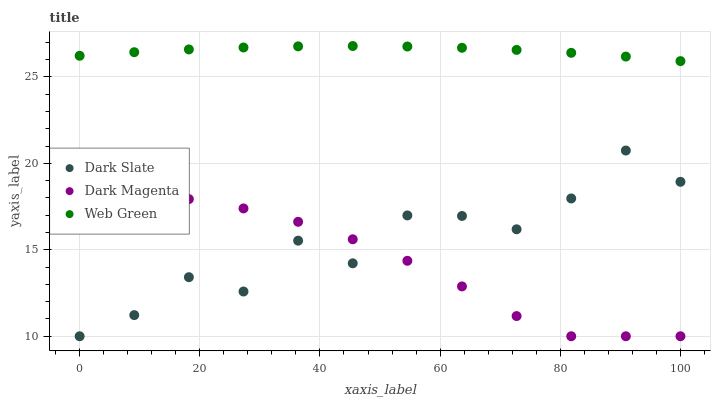Does Dark Magenta have the minimum area under the curve?
Answer yes or no. Yes. Does Web Green have the maximum area under the curve?
Answer yes or no. Yes. Does Web Green have the minimum area under the curve?
Answer yes or no. No. Does Dark Magenta have the maximum area under the curve?
Answer yes or no. No. Is Web Green the smoothest?
Answer yes or no. Yes. Is Dark Slate the roughest?
Answer yes or no. Yes. Is Dark Magenta the smoothest?
Answer yes or no. No. Is Dark Magenta the roughest?
Answer yes or no. No. Does Dark Slate have the lowest value?
Answer yes or no. Yes. Does Web Green have the lowest value?
Answer yes or no. No. Does Web Green have the highest value?
Answer yes or no. Yes. Does Dark Magenta have the highest value?
Answer yes or no. No. Is Dark Magenta less than Web Green?
Answer yes or no. Yes. Is Web Green greater than Dark Slate?
Answer yes or no. Yes. Does Dark Magenta intersect Dark Slate?
Answer yes or no. Yes. Is Dark Magenta less than Dark Slate?
Answer yes or no. No. Is Dark Magenta greater than Dark Slate?
Answer yes or no. No. Does Dark Magenta intersect Web Green?
Answer yes or no. No. 